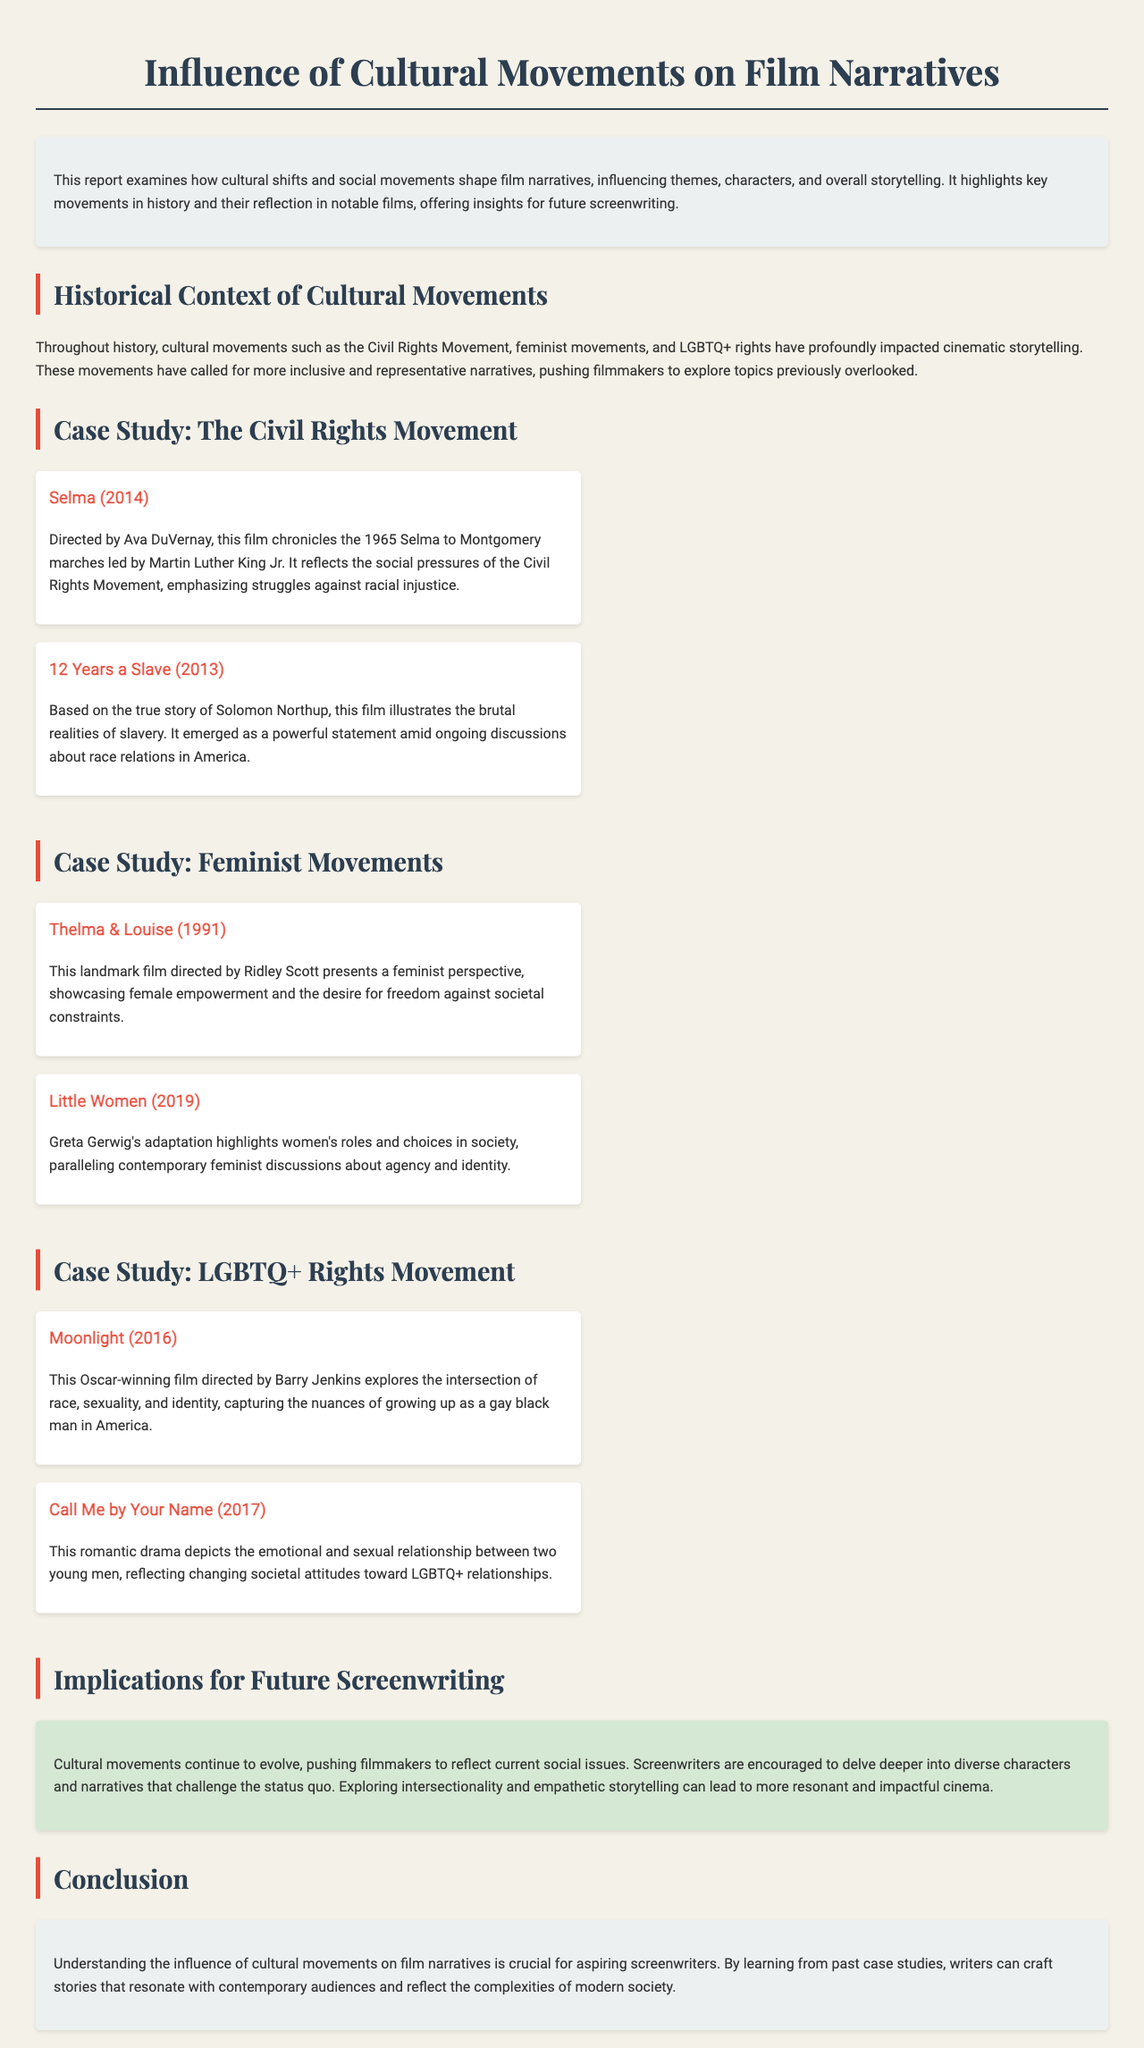What are some examples of films reflecting the Civil Rights Movement? The document lists "Selma" and "12 Years a Slave" as examples of films that reflect the Civil Rights Movement.
Answer: Selma, 12 Years a Slave Who directed "Thelma & Louise"? The report indicates that "Thelma & Louise" was directed by Ridley Scott.
Answer: Ridley Scott What year was "Little Women" released? The case study section mentions that "Little Women" was released in 2019.
Answer: 2019 Which film explores the intersection of race and sexuality? The document states that "Moonlight" explores the intersection of race, sexuality, and identity.
Answer: Moonlight What thematic focus do feminist movements influence in film? The report discusses the influence of feminist movements on themes of female empowerment and societal constraints.
Answer: Female empowerment What aspect of LGBTQ+ relationships does "Call Me by Your Name" reflect? The document describes "Call Me by Your Name" as reflecting changing societal attitudes toward LGBTQ+ relationships.
Answer: Societal attitudes What is a recommended approach for future screenwriters according to the report? It is suggested that future screenwriters should explore diverse characters and narratives that challenge the status quo.
Answer: Diverse characters Which cultural movements are mentioned in the document? The report highlights the Civil Rights Movement, feminist movements, and LGBTQ+ rights as significant cultural movements.
Answer: Civil Rights Movement, feminist movements, LGBTQ+ rights 